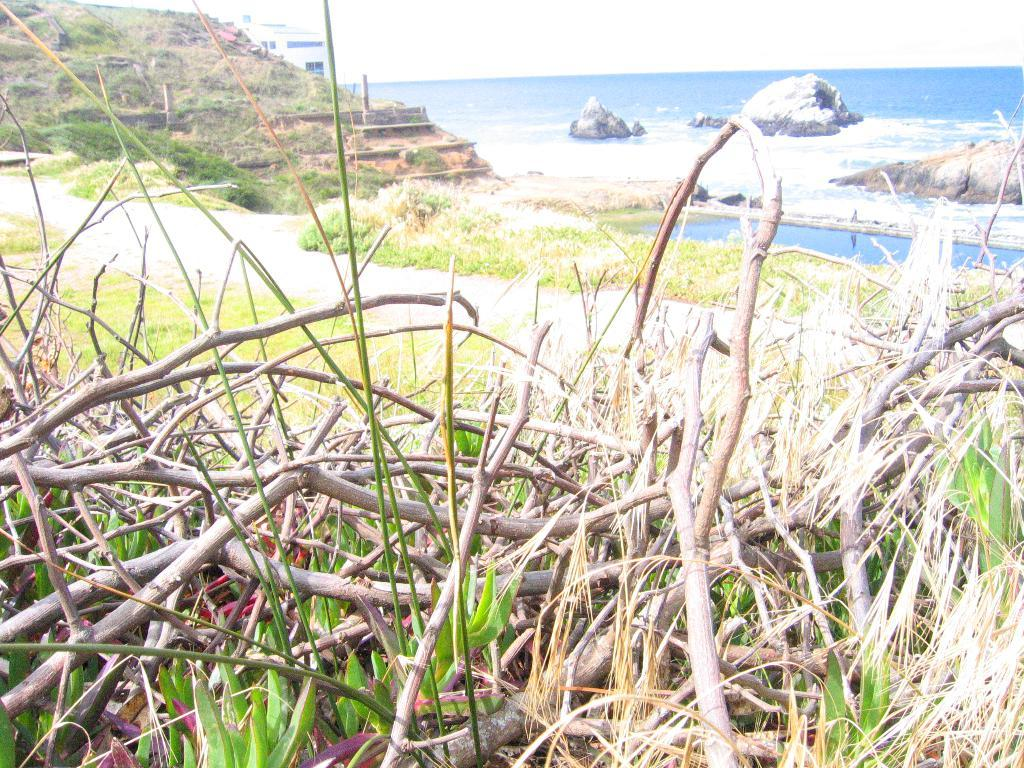What type of natural environment is depicted in the image? The image contains woods, grass, plants, and water, which suggests a natural environment such as a forest or park. Can you describe the vegetation in the image? There are woods, grass, and plants visible in the image. What is the water feature in the image? There is water visible in the image, and rocks are present in the water. Who is the owner of the tank in the image? There is no tank present in the image, so it is not possible to determine the owner. 